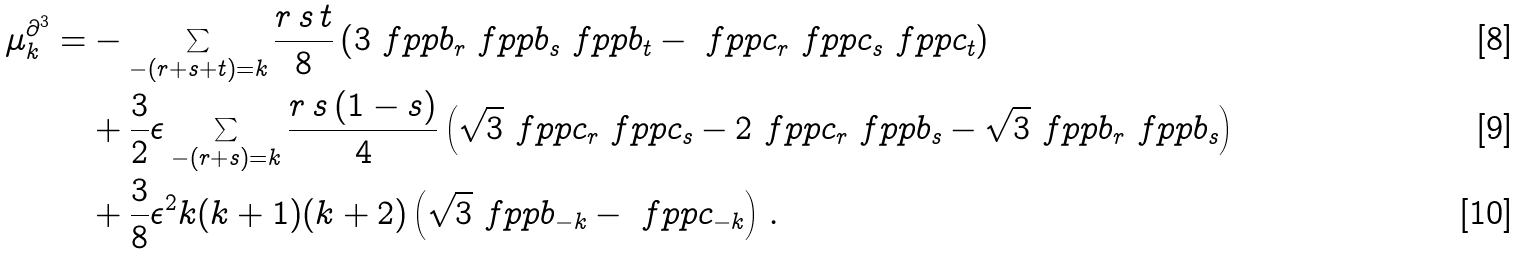<formula> <loc_0><loc_0><loc_500><loc_500>\mu _ { k } ^ { \partial ^ { 3 } } = & - \sum _ { - ( r + s + t ) = k } \frac { r \, s \, t } 8 \left ( 3 \ f p p { b _ { r } } \ f p p { b _ { s } } \ f p p { b _ { t } } - \ f p p { c _ { r } } \ f p p { c _ { s } } \ f p p { c _ { t } } \right ) \\ & + \frac { 3 } { 2 } \epsilon \sum _ { - ( r + s ) = k } \frac { r \, s \, ( 1 - s ) } 4 \left ( \sqrt { 3 } \ f p p { c _ { r } } \ f p p { c _ { s } } - 2 \ f p p { c _ { r } } \ f p p { b _ { s } } - \sqrt { 3 } \ f p p { b _ { r } } \ f p p { b _ { s } } \right ) \\ & + \frac { 3 } { 8 } \epsilon ^ { 2 } k ( k + 1 ) ( k + 2 ) \left ( \sqrt { 3 } \ f p p { b _ { - k } } - \ f p p { c _ { - k } } \right ) \, .</formula> 